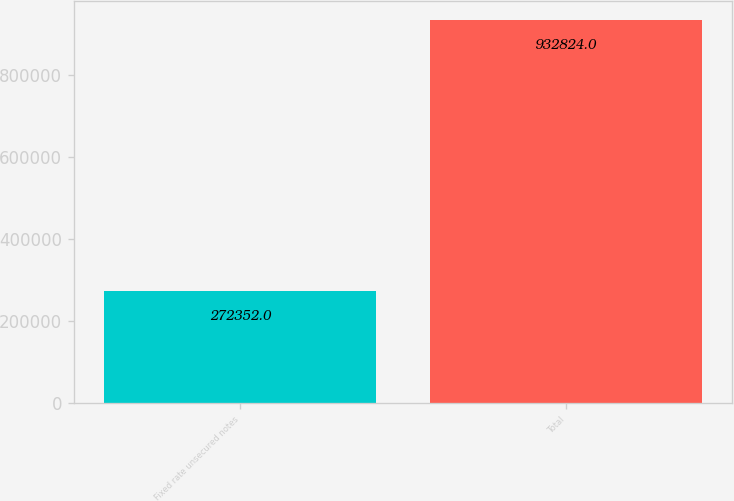Convert chart to OTSL. <chart><loc_0><loc_0><loc_500><loc_500><bar_chart><fcel>Fixed rate unsecured notes<fcel>Total<nl><fcel>272352<fcel>932824<nl></chart> 